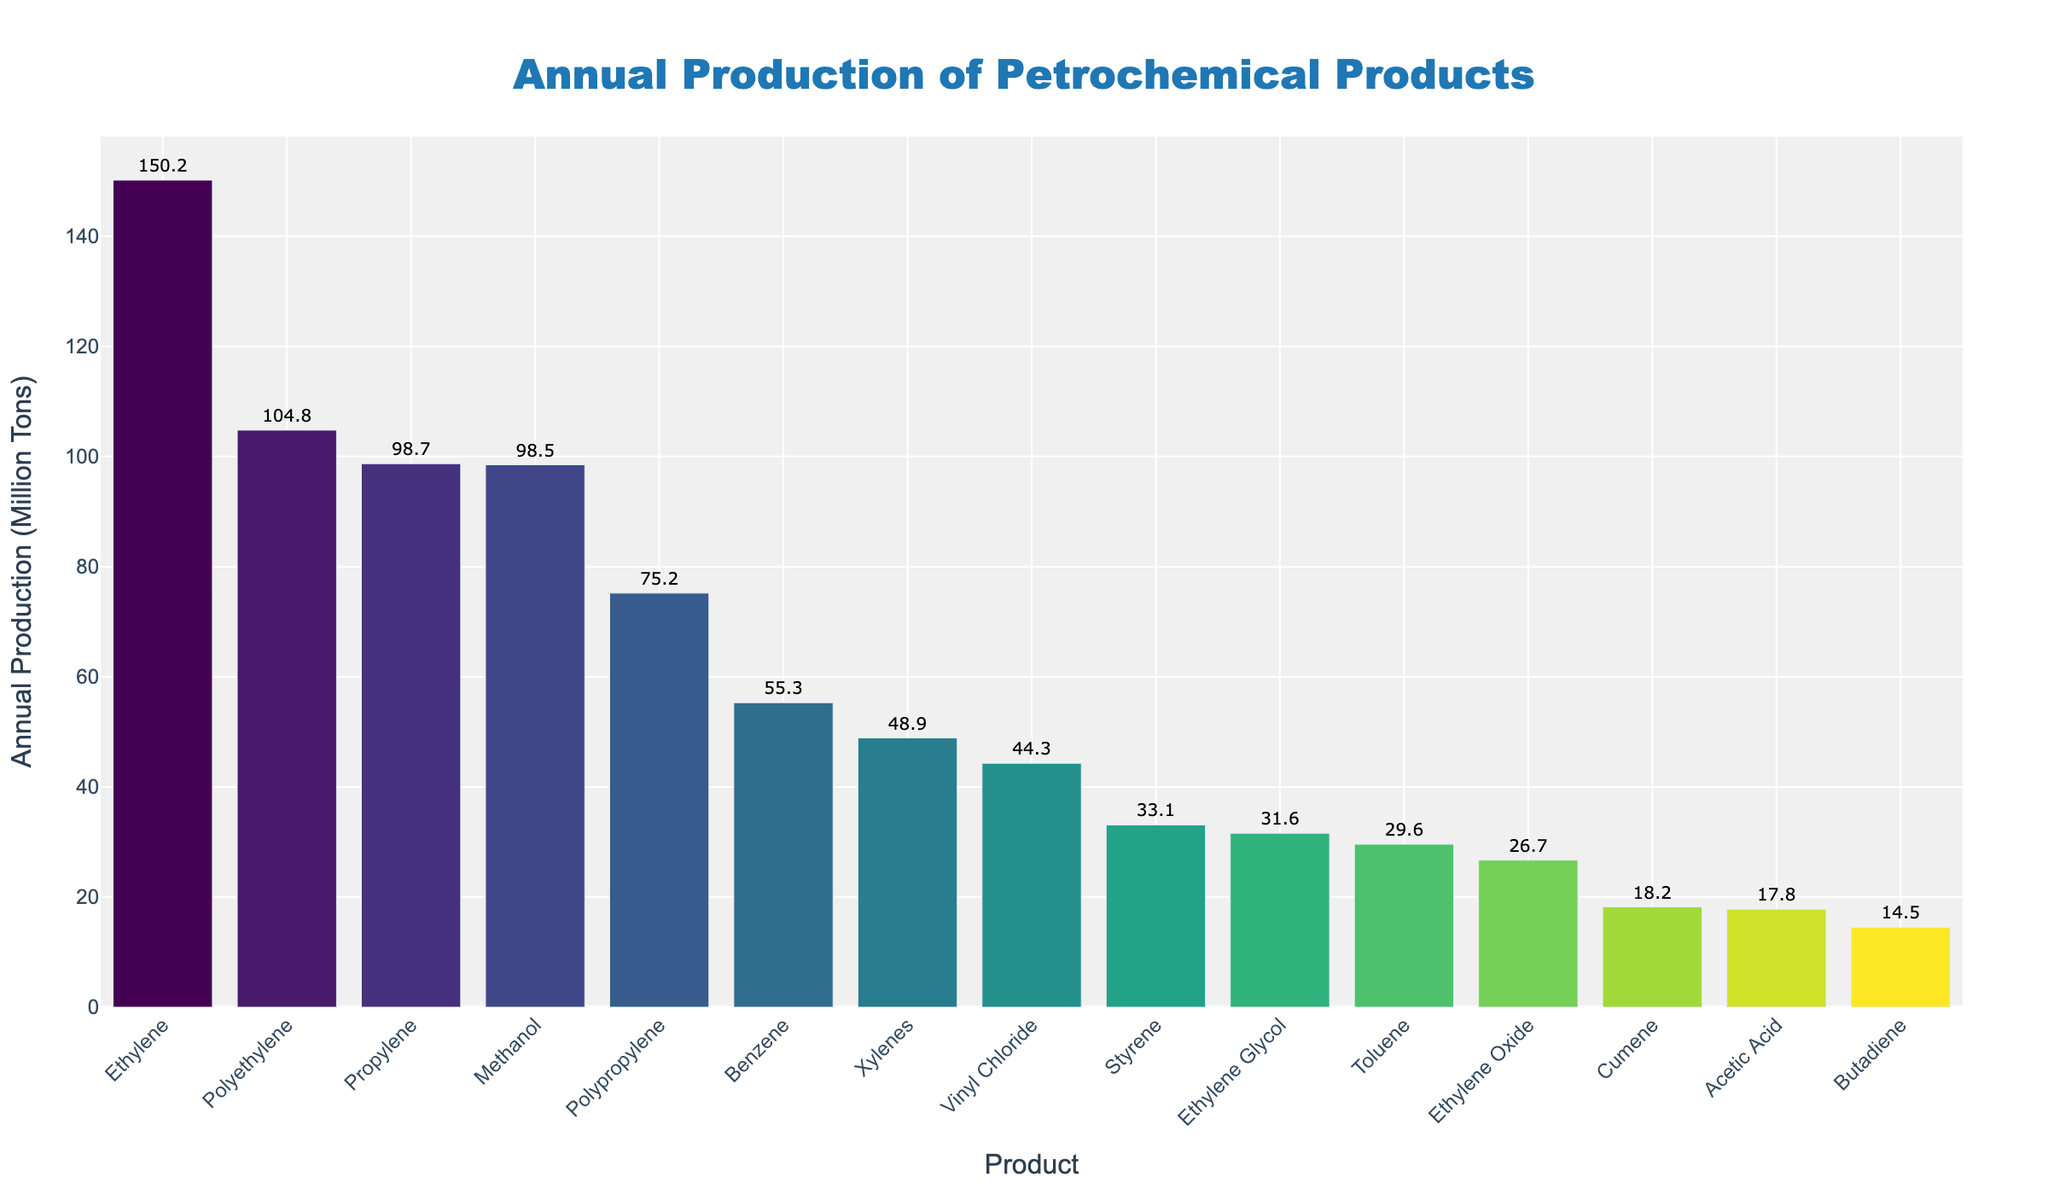What is the highest annual production volume among the petrochemical products? The highest bar indicates the product with the highest annual production volume. According to the chart, Ethylene has the highest annual production volume of 150.2 million tons.
Answer: 150.2 million tons Which product has the lowest annual production volume? The lowest bar represents the product with the lowest annual production volume. The chart shows that Butadiene has the lowest annual production volume of 14.5 million tons.
Answer: 14.5 million tons How does the annual production volume of Propylene compare to Methanol? By comparing the heights of the bars for Propylene and Methanol, we see that Propylene (98.7 million tons) has a slightly higher production volume than Methanol (98.5 million tons).
Answer: Propylene is slightly higher What is the combined annual production volume of Xylenes and Toluene? To find the combined annual production volume, add the values for Xylenes (48.9 million tons) and Toluene (29.6 million tons). So, 48.9 + 29.6 = 78.5 million tons.
Answer: 78.5 million tons What is the average production volume of Benzene, Styrene, and Vinyl Chloride? The average is calculated by summing the volumes and dividing by the number of products: (55.3 + 33.1 + 44.3) / 3. So, (132.7) / 3 = 44.23 million tons.
Answer: 44.2 million tons What is the difference in annual production volume between Polyethylene and Polypropylene? To find the difference, subtract the production volume of Polypropylene (75.2 million tons) from Polyethylene (104.8 million tons). So, 104.8 - 75.2 = 29.6 million tons.
Answer: 29.6 million tons Which products have an annual production volume greater than 50 million tons? By observing the chart, the products with bars exceeding 50 million tons are Ethylene, Propylene, Methanol, and Polyethylene.
Answer: Ethylene, Propylene, Methanol, Polyethylene How much more Ethylene is produced compared to Cumene? Subtract the production volume of Cumene (18.2 million tons) from Ethylene (150.2 million tons). So, 150.2 - 18.2 = 132 million tons.
Answer: 132 million tons What is the total annual production volume of all products combined? Sum the production volumes for all products: 150.2 + 98.7 + 55.3 + 48.9 + 98.5 + 31.6 + 104.8 + 75.2 + 33.1 + 14.5 + 17.8 + 44.3 + 29.6 + 18.2 + 26.7 = 847.4 million tons.
Answer: 847.4 million tons 